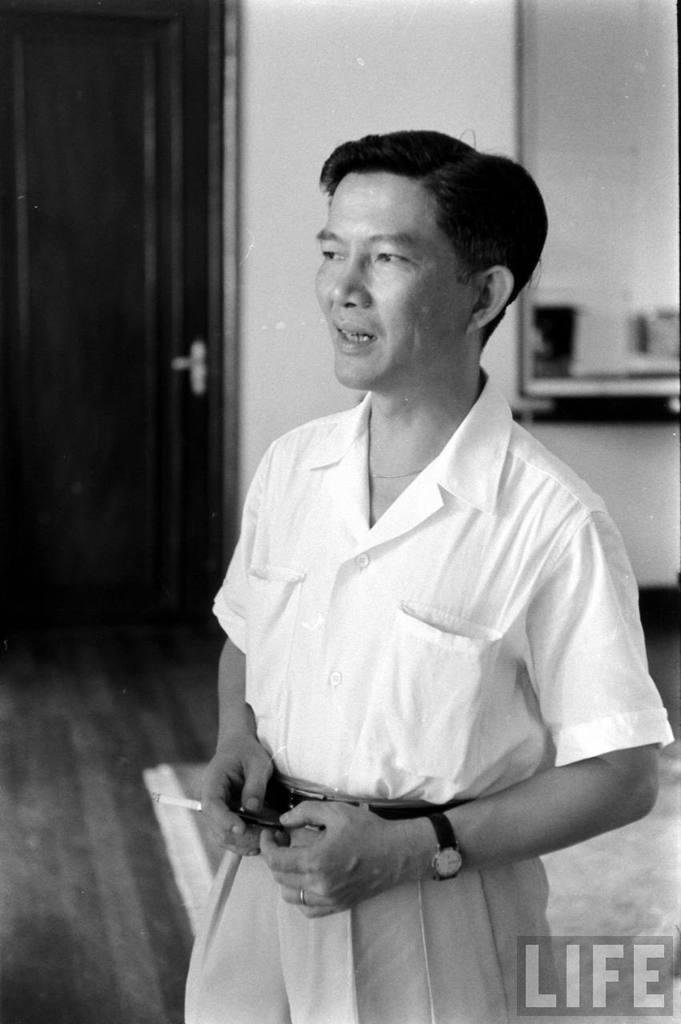What is the color scheme of the image? The image is in black and white. Can you describe the person in the image? There is a person in the image, and they are wearing a shirt. What is the person holding in their hand? The person is holding a cigarette in their hand. What type of flooring is visible in the image? The person is standing on a floor with a carpet. Where is the door located in the image? There is a door on the left side of the image, attached to a wall. What type of waves can be seen in the image? There are no waves present in the image; it is a black and white image of a person standing on a carpeted floor with a door on the left side. 